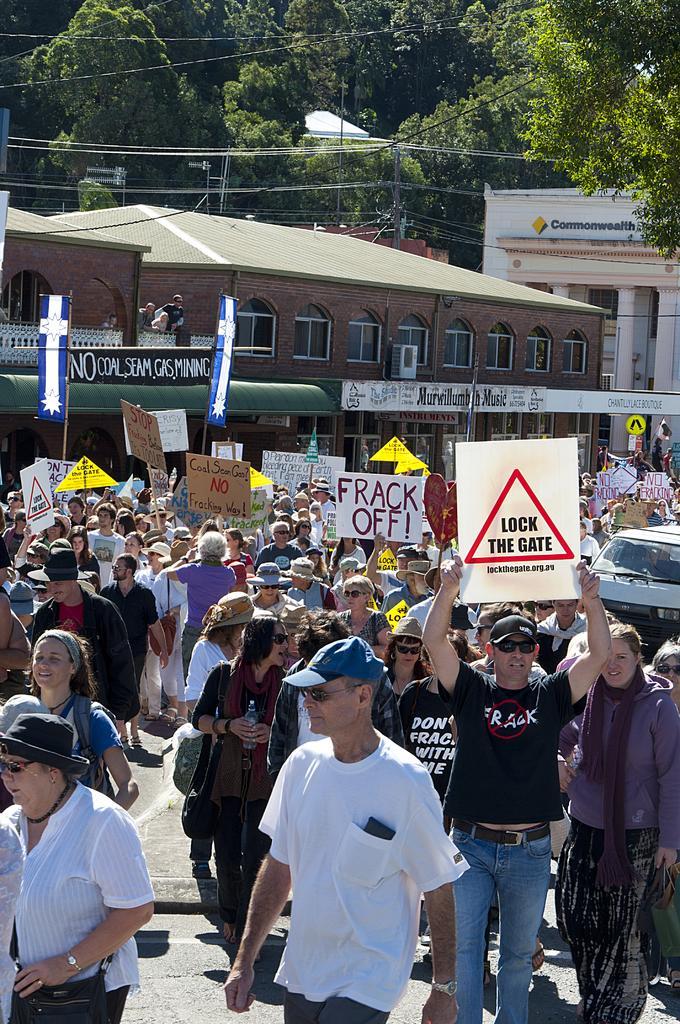Could you give a brief overview of what you see in this image? In the image we can see there are people standing on the road and they are holding pluck cards in their hand. Behind there are buildings and there are trees. 